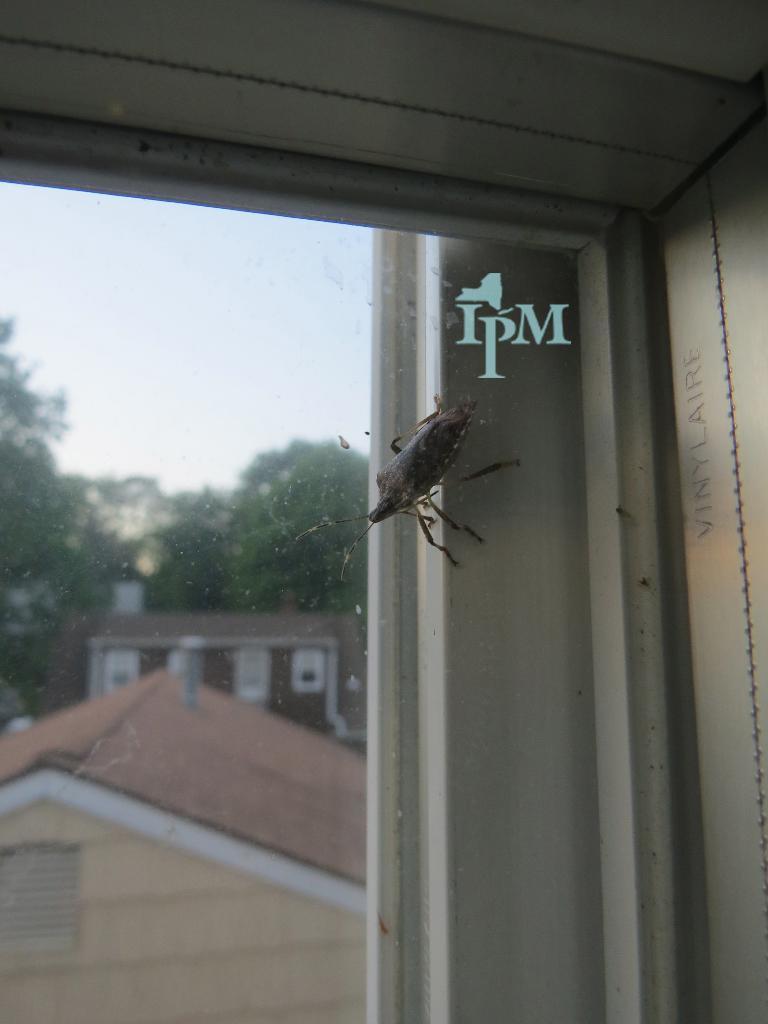Please provide a concise description of this image. In this picture I can see a window glass in front and on it I can see an insect. Through the glass I can see number of buildings and trees. I can also see something is written on the glass. In the middle of this picture I can see the sky. On the right side of this picture I can see a word written. 